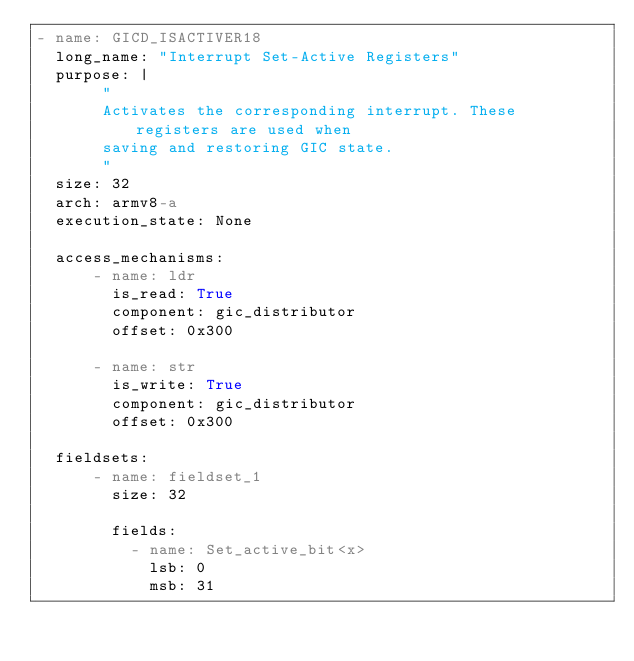<code> <loc_0><loc_0><loc_500><loc_500><_YAML_>- name: GICD_ISACTIVER18
  long_name: "Interrupt Set-Active Registers"
  purpose: |
       "
       Activates the corresponding interrupt. These registers are used when
       saving and restoring GIC state.
       "
  size: 32
  arch: armv8-a
  execution_state: None

  access_mechanisms:
      - name: ldr
        is_read: True
        component: gic_distributor
        offset: 0x300

      - name: str
        is_write: True
        component: gic_distributor
        offset: 0x300

  fieldsets:
      - name: fieldset_1
        size: 32

        fields:
          - name: Set_active_bit<x>
            lsb: 0
            msb: 31
</code> 